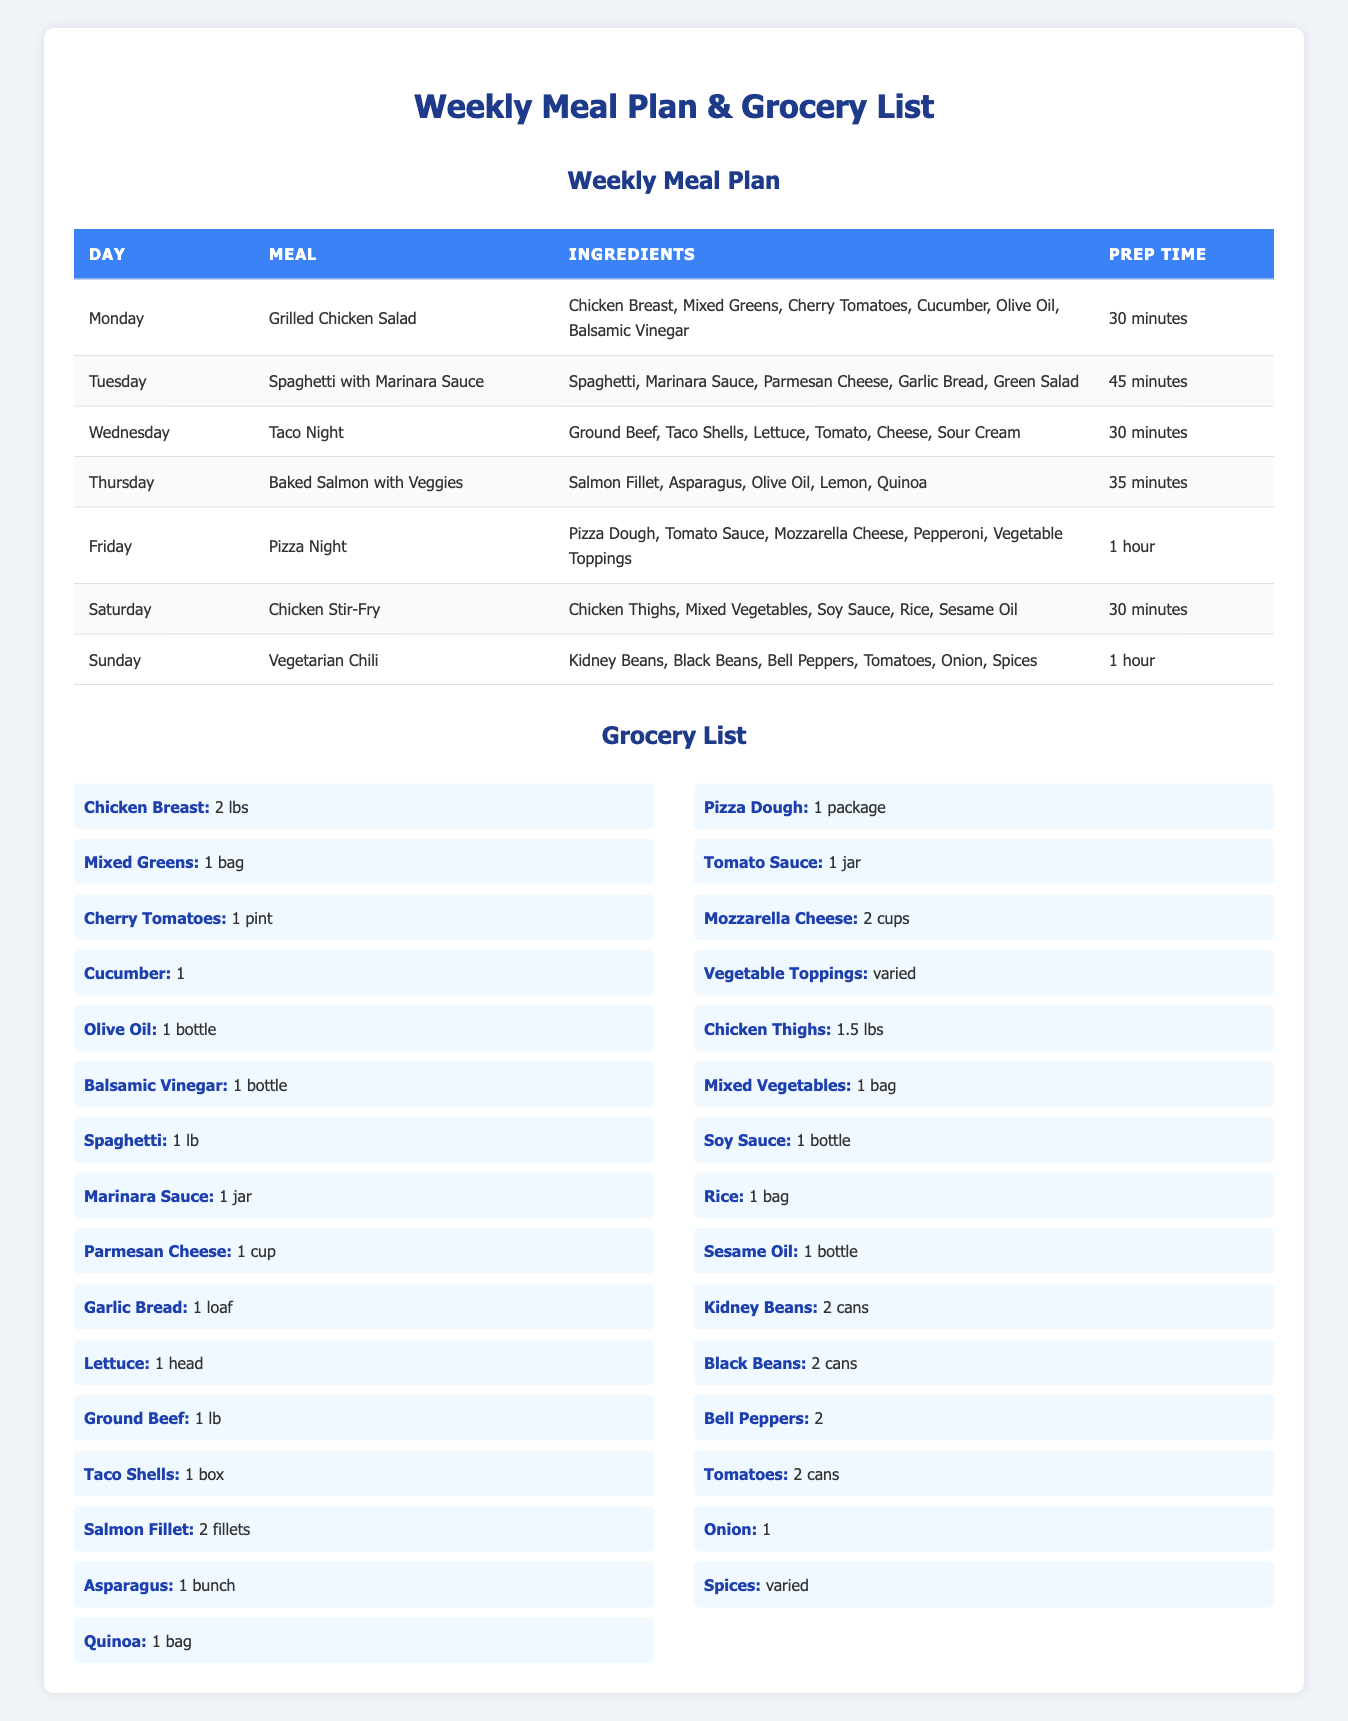What is the meal planned for Wednesday? The meal planned for Wednesday is found in the "Day" column under "Wednesday," which corresponds to "Taco Night" in the "Meal" column.
Answer: Taco Night How many ingredients are needed for Baked Salmon with Veggies? For Baked Salmon with Veggies, the ingredients listed are: Salmon Fillet, Asparagus, Olive Oil, Lemon, and Quinoa. There are a total of 5 ingredients.
Answer: 5 Which meal takes the longest to prepare? The table shows that "Pizza Night" has a prep time of 1 hour, which is the longest compared to other meals.
Answer: Pizza Night Are any of the meals vegetarian? Reviewing the meals in the table, "Vegetarian Chili" is explicitly labeled as vegetarian, making it true.
Answer: Yes What is the total preparation time for the meals from Monday to Thursday? The prep times are: Monday 30 minutes, Tuesday 45 minutes, Wednesday 30 minutes, and Thursday 35 minutes. Adding these gives 30 + 45 + 30 + 35 = 140 minutes.
Answer: 140 minutes How many different proteins are included in the meals? The proteins mentioned in the meals are chicken (Grilled Chicken Salad, Chicken Stir-Fry), ground beef (Taco Night), salmon (Baked Salmon with Veggies), and cheese (as in Pizza Night). In total, there are 3 distinctive proteins counted (chicken, beef, salmon).
Answer: 3 What ingredients are used for Taco Night? Looking at the ingredients for Taco Night, they are: Ground Beef, Taco Shells, Lettuce, Tomato, Cheese, and Sour Cream.
Answer: Ground Beef, Taco Shells, Lettuce, Tomato, Cheese, Sour Cream How many cans of tomatoes are needed according to the grocery list? From the grocery list, there are 2 cans needed for tomatoes as indicated under "Tomatoes."
Answer: 2 cans 